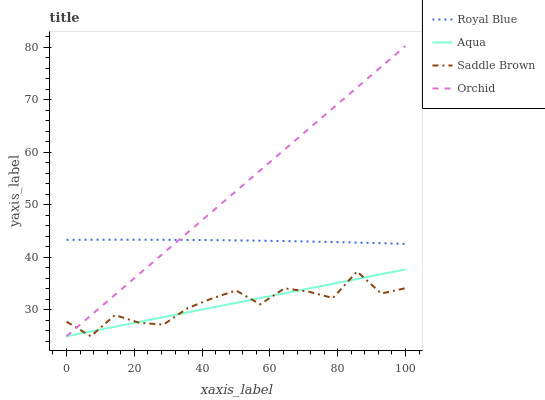Does Saddle Brown have the minimum area under the curve?
Answer yes or no. Yes. Does Orchid have the maximum area under the curve?
Answer yes or no. Yes. Does Aqua have the minimum area under the curve?
Answer yes or no. No. Does Aqua have the maximum area under the curve?
Answer yes or no. No. Is Aqua the smoothest?
Answer yes or no. Yes. Is Saddle Brown the roughest?
Answer yes or no. Yes. Is Saddle Brown the smoothest?
Answer yes or no. No. Is Aqua the roughest?
Answer yes or no. No. Does Aqua have the lowest value?
Answer yes or no. Yes. Does Orchid have the highest value?
Answer yes or no. Yes. Does Aqua have the highest value?
Answer yes or no. No. Is Aqua less than Royal Blue?
Answer yes or no. Yes. Is Royal Blue greater than Saddle Brown?
Answer yes or no. Yes. Does Royal Blue intersect Orchid?
Answer yes or no. Yes. Is Royal Blue less than Orchid?
Answer yes or no. No. Is Royal Blue greater than Orchid?
Answer yes or no. No. Does Aqua intersect Royal Blue?
Answer yes or no. No. 